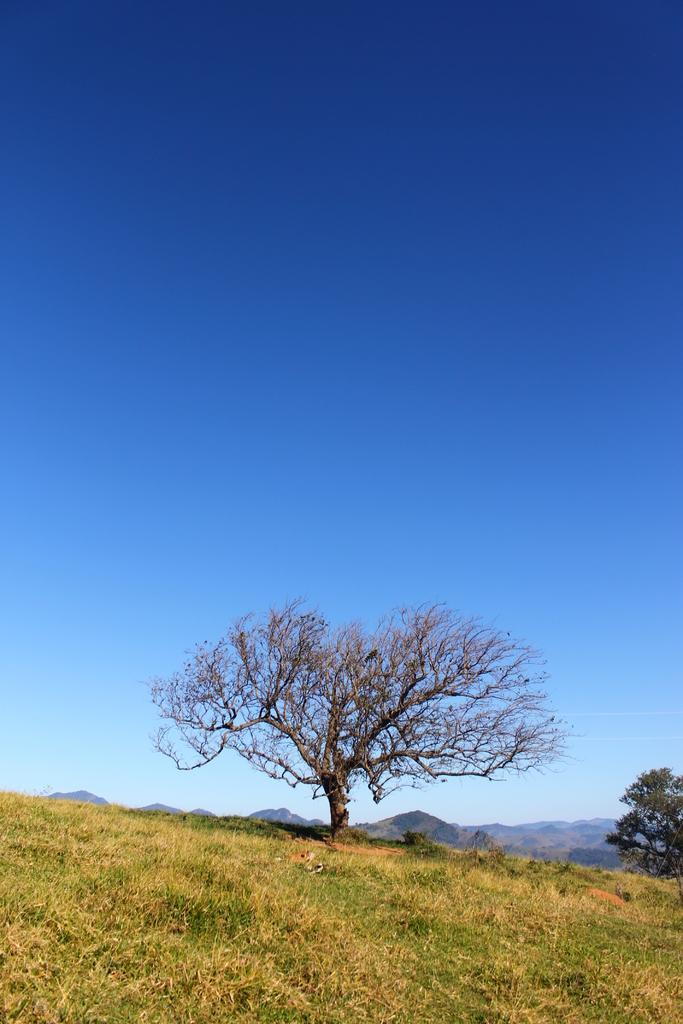In one or two sentences, can you explain what this image depicts? In the image we can see a trees, grass, mountain and a pale blue sky. We can even see a bird sitting on the tree. 